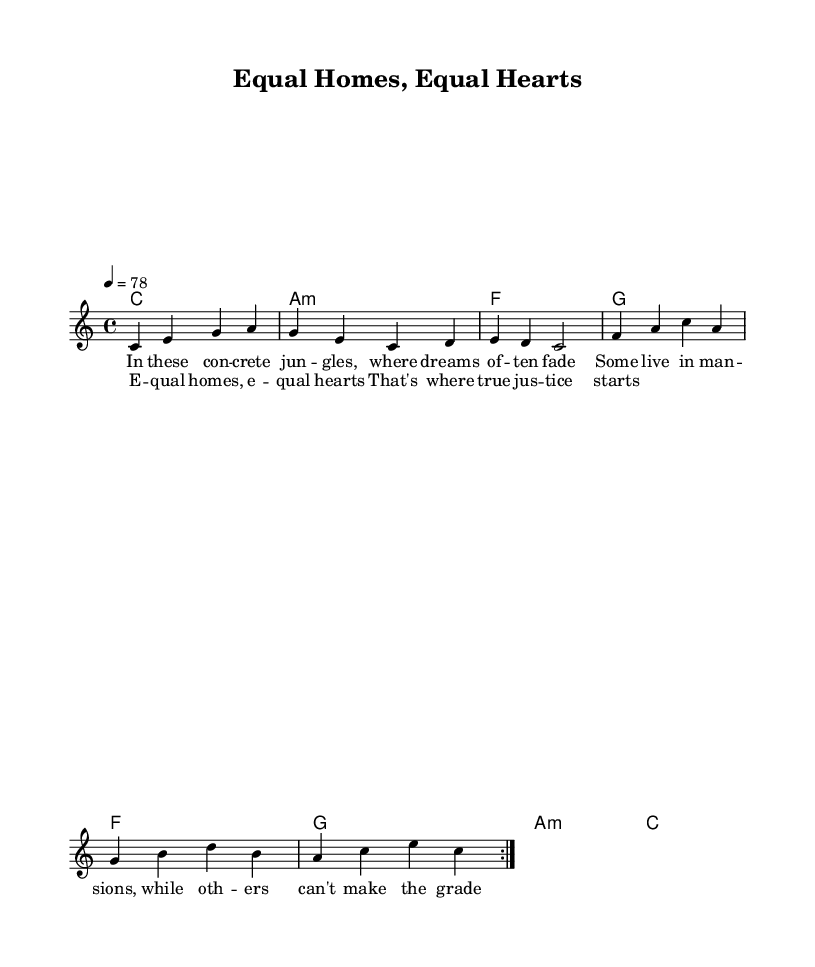What is the key signature of this music? The key signature is C major, which has no sharps or flats.
Answer: C major What is the time signature of this music? The time signature is indicated as 4/4, meaning there are four beats per measure and the quarter note gets one beat.
Answer: 4/4 What is the tempo marking for this piece? The tempo marking indicates a speed of 78 beats per minute, as noted by the tempo marking "4 = 78".
Answer: 78 How many times is the melody repeated before moving on? The melody is indicated to be repeated twice as specified by the "volta 2" notation.
Answer: 2 What is the thematic focus of the lyrics in this track? The lyrics focus on social inequality and housing issues, as suggested by phrases like "equal homes" and "where dreams often fade."
Answer: Social inequality What chord follows the lyric "Equal homes, equal hearts"? The chord after the words "Equal homes, equal hearts" corresponds to the chord that is indicated at that measure, which is noted to be G.
Answer: G What is the overall feeling or mood conveyed by the reggae genre in this piece? The overall feeling conveyed is uplifting, with a focus on positivity and social justice reflected in both the lyrics and the reggae rhythm.
Answer: Uplifting 